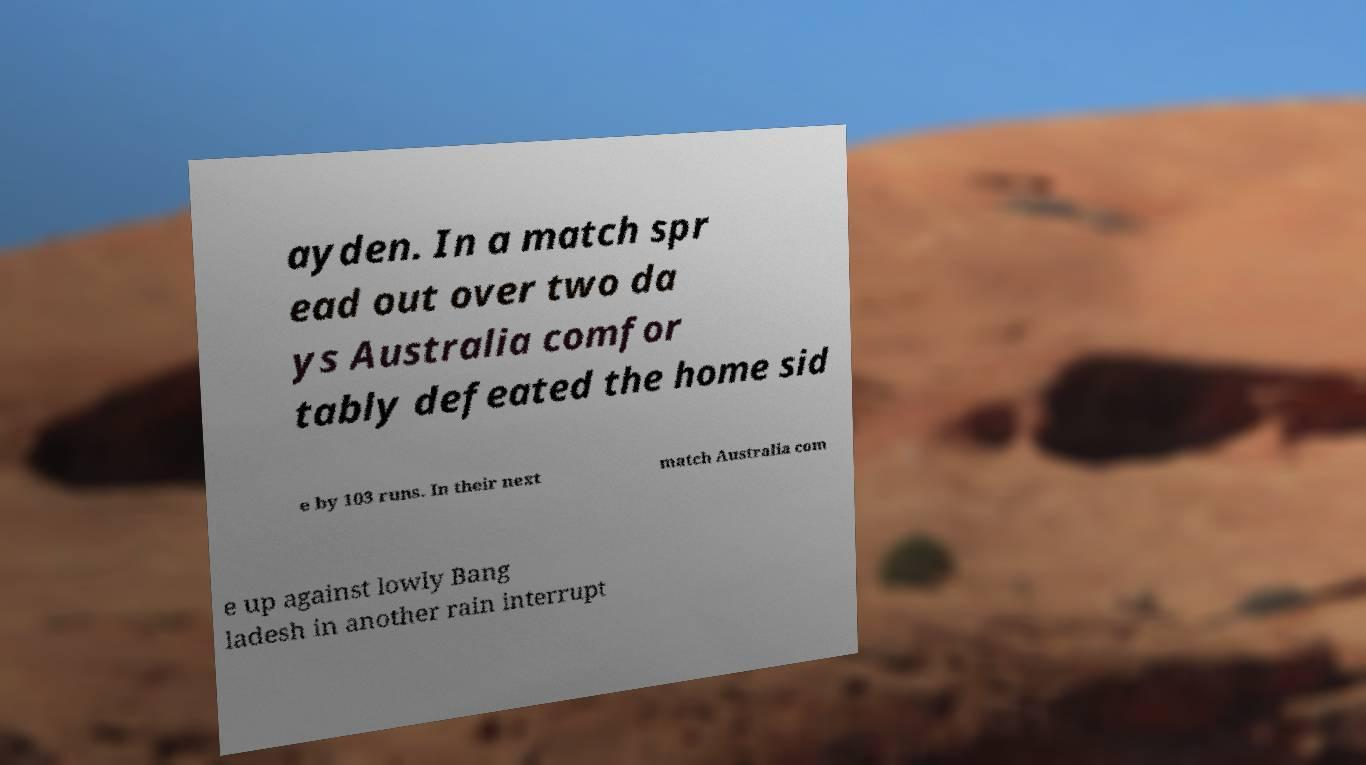Can you accurately transcribe the text from the provided image for me? ayden. In a match spr ead out over two da ys Australia comfor tably defeated the home sid e by 103 runs. In their next match Australia com e up against lowly Bang ladesh in another rain interrupt 